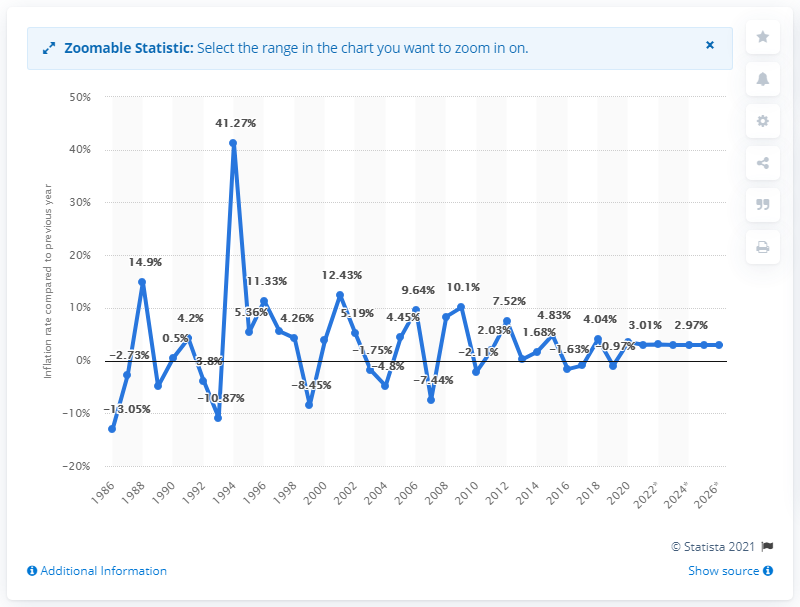Identify some key points in this picture. In 2020, the inflation rate in Chad was 3.48%. 